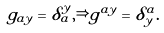<formula> <loc_0><loc_0><loc_500><loc_500>g _ { a y } = \delta ^ { y } _ { a } , \Rightarrow g ^ { a y } = \delta _ { y } ^ { a } .</formula> 